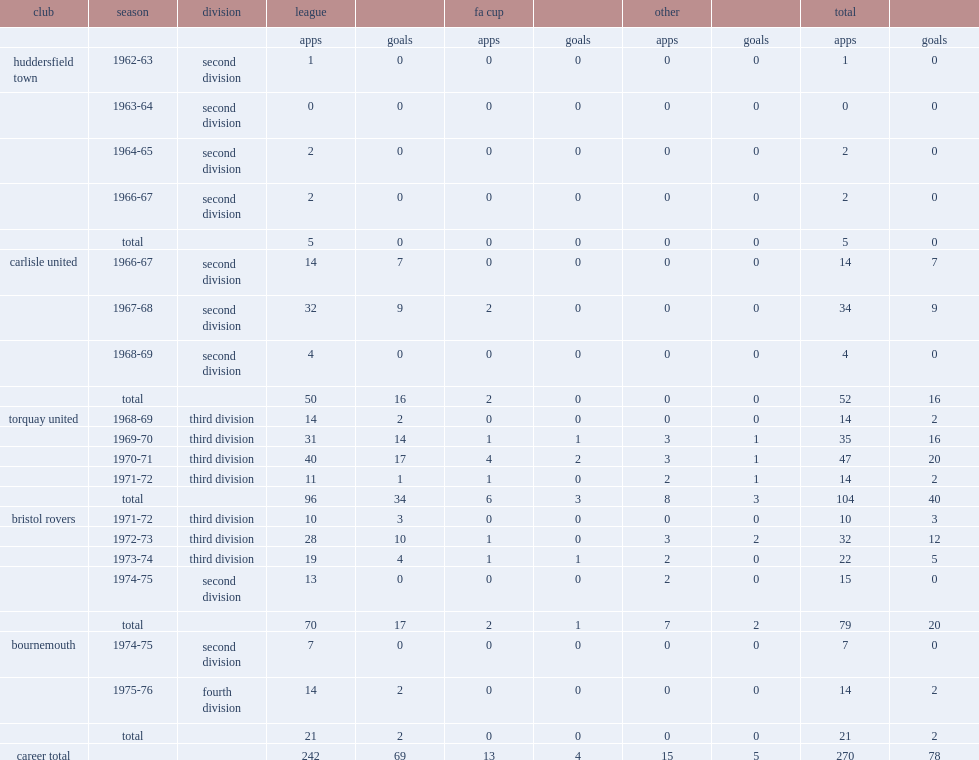Which club did john rudge play for in 1968-69? Torquay united. 